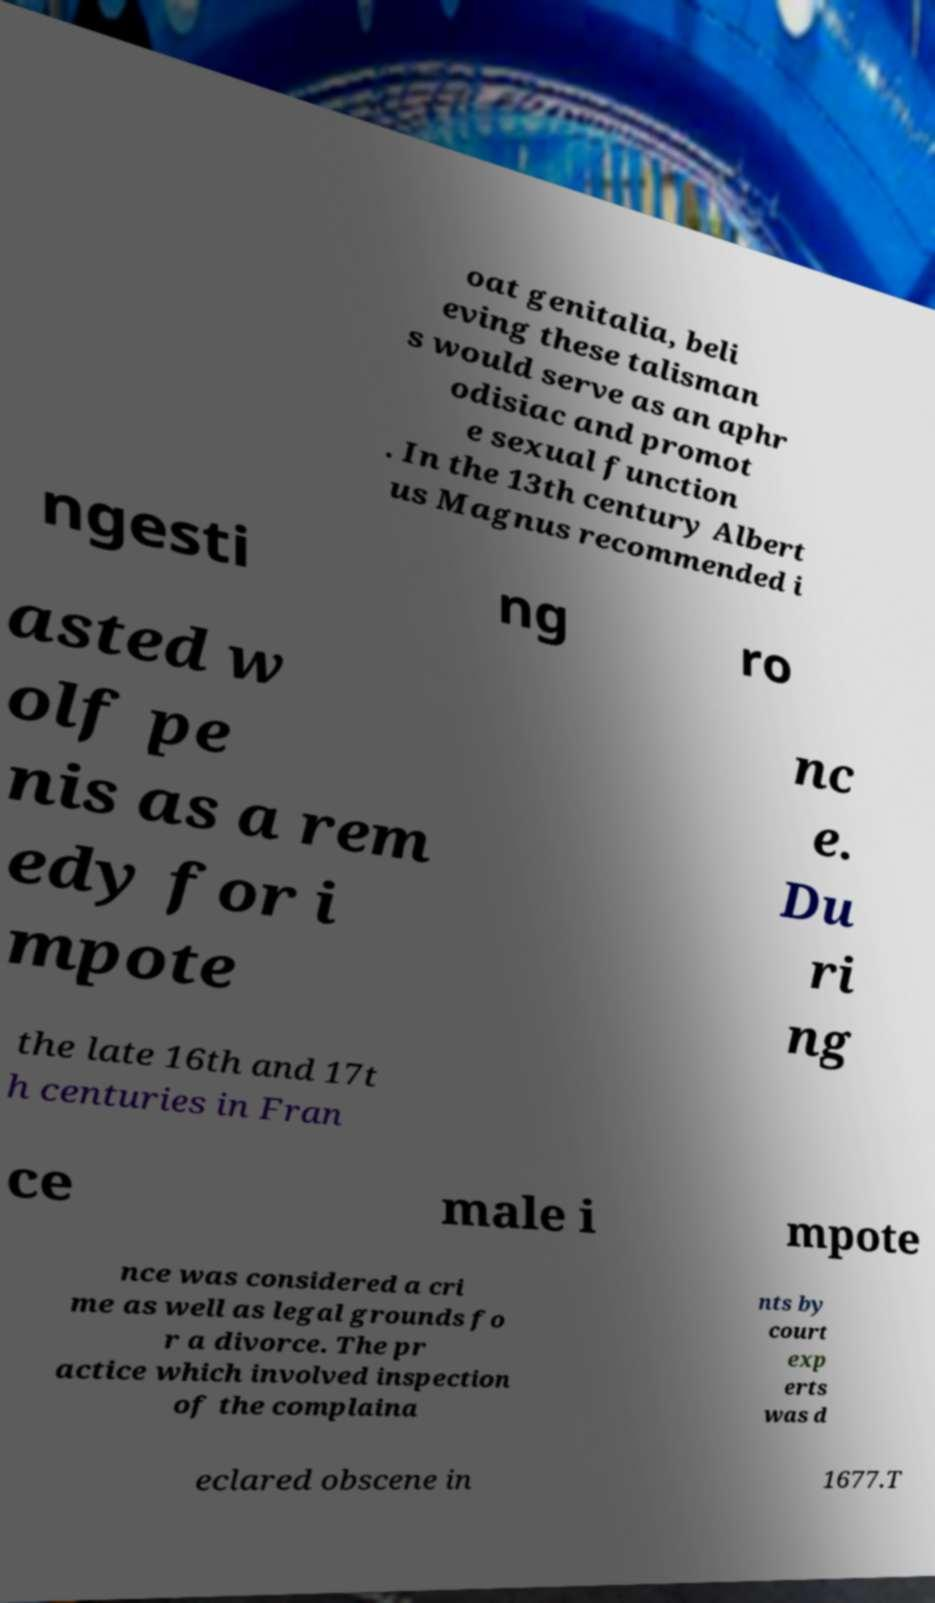Could you assist in decoding the text presented in this image and type it out clearly? oat genitalia, beli eving these talisman s would serve as an aphr odisiac and promot e sexual function . In the 13th century Albert us Magnus recommended i ngesti ng ro asted w olf pe nis as a rem edy for i mpote nc e. Du ri ng the late 16th and 17t h centuries in Fran ce male i mpote nce was considered a cri me as well as legal grounds fo r a divorce. The pr actice which involved inspection of the complaina nts by court exp erts was d eclared obscene in 1677.T 